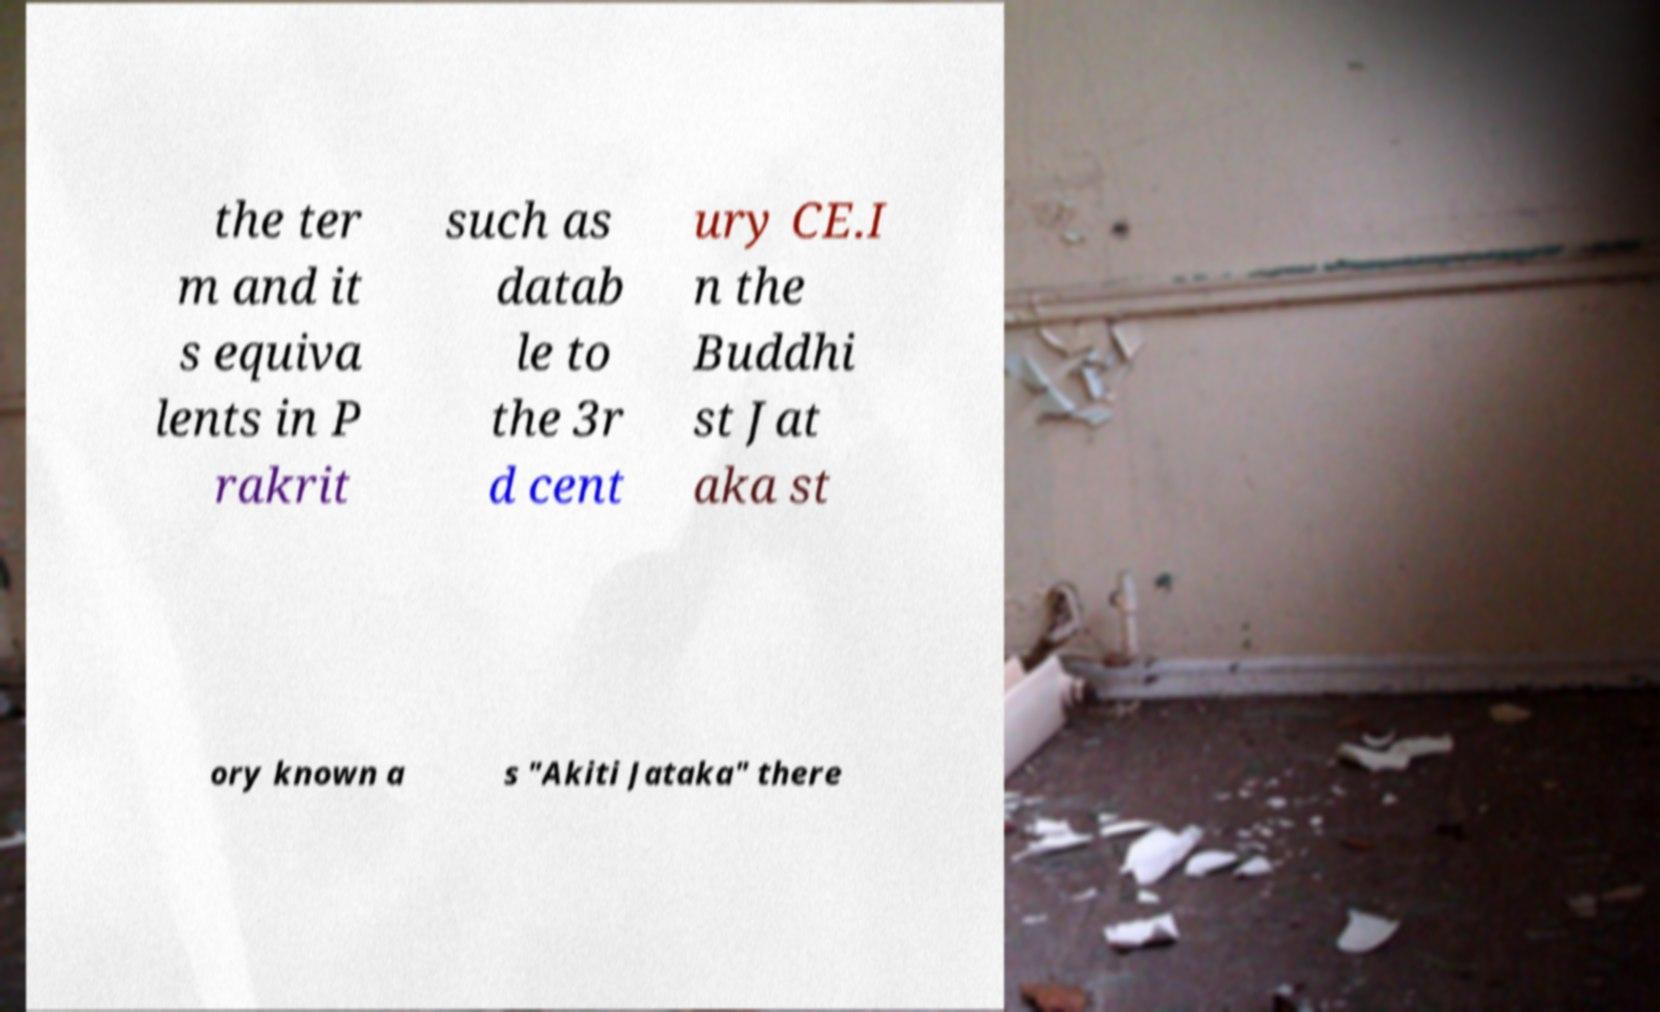Please identify and transcribe the text found in this image. the ter m and it s equiva lents in P rakrit such as datab le to the 3r d cent ury CE.I n the Buddhi st Jat aka st ory known a s "Akiti Jataka" there 